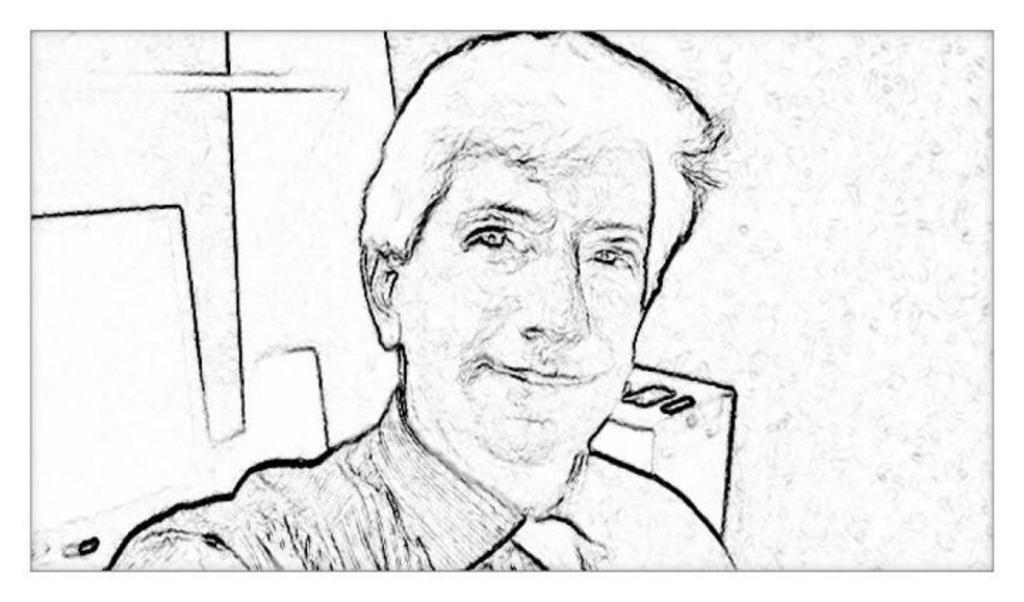What is the color scheme of the image? The image is in black and white. What is depicted in the image? There is a sketch of a person in the image. What is the person in the sketch wearing? The person in the sketch is wearing a shirt. How many scarecrows are present in the image? There are no scarecrows present in the image; it features a sketch of a person wearing a shirt. How long does it take for the person in the sketch to complete a minute task? The image does not provide information about the person's actions or abilities, so it is impossible to determine how long it would take them to complete a task. 